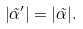<formula> <loc_0><loc_0><loc_500><loc_500>\left | \tilde { \alpha } ^ { \prime } \right | = | \tilde { \alpha } | .</formula> 